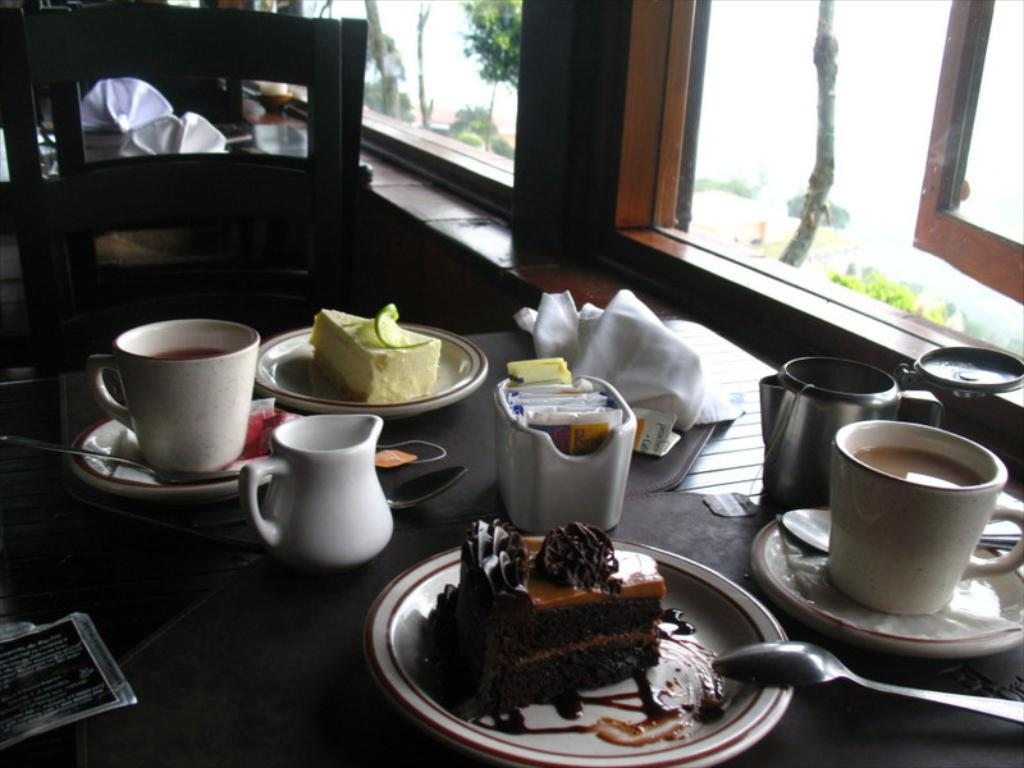What type of furniture is present in the image? There is a table in the image. What objects are placed on the table? There are cups and plates on the table. Is there any food visible on the table? Yes, there is food on the table. What can be seen through the window in the image? The presence of a window is mentioned, but no specific details about what can be seen through it are provided. What type of force is being applied to the cups on the table? There is no indication of any force being applied to the cups in the image. 